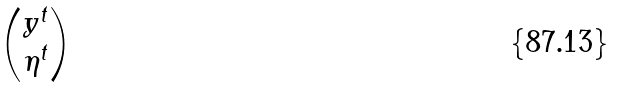Convert formula to latex. <formula><loc_0><loc_0><loc_500><loc_500>\begin{pmatrix} y ^ { t } \\ \eta ^ { t } \end{pmatrix}</formula> 